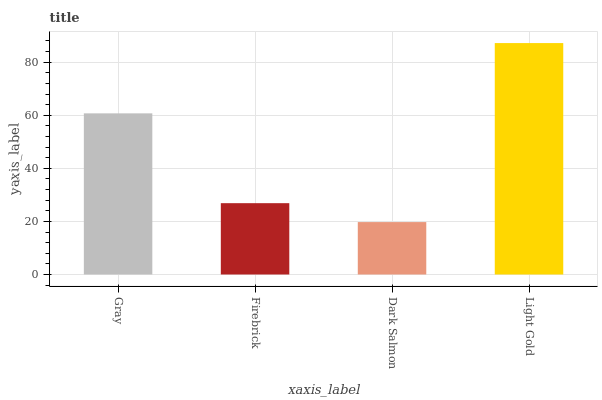Is Dark Salmon the minimum?
Answer yes or no. Yes. Is Light Gold the maximum?
Answer yes or no. Yes. Is Firebrick the minimum?
Answer yes or no. No. Is Firebrick the maximum?
Answer yes or no. No. Is Gray greater than Firebrick?
Answer yes or no. Yes. Is Firebrick less than Gray?
Answer yes or no. Yes. Is Firebrick greater than Gray?
Answer yes or no. No. Is Gray less than Firebrick?
Answer yes or no. No. Is Gray the high median?
Answer yes or no. Yes. Is Firebrick the low median?
Answer yes or no. Yes. Is Firebrick the high median?
Answer yes or no. No. Is Gray the low median?
Answer yes or no. No. 